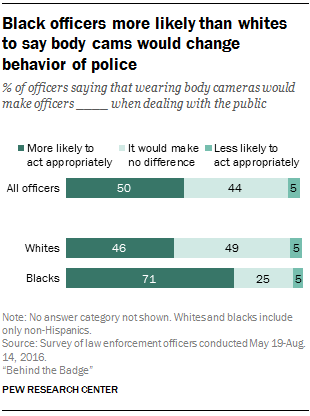Give some essential details in this illustration. According to the survey, 0.46% of White officers believe that wearing body cameras would make them more likely to act appropriately. What is the frequency of 'bar' with a value of 5? 